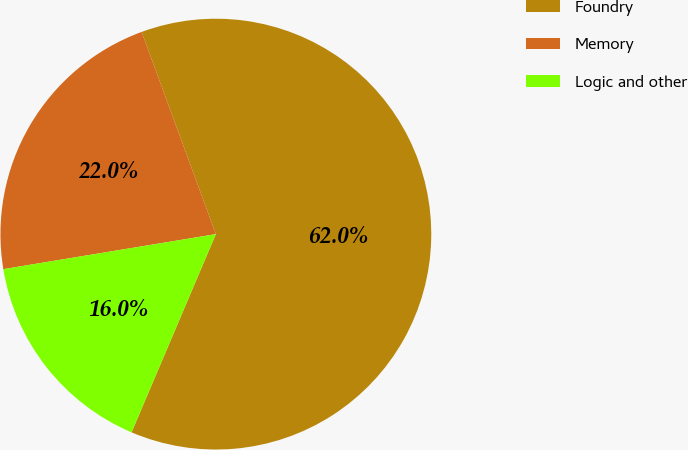<chart> <loc_0><loc_0><loc_500><loc_500><pie_chart><fcel>Foundry<fcel>Memory<fcel>Logic and other<nl><fcel>62.0%<fcel>22.0%<fcel>16.0%<nl></chart> 